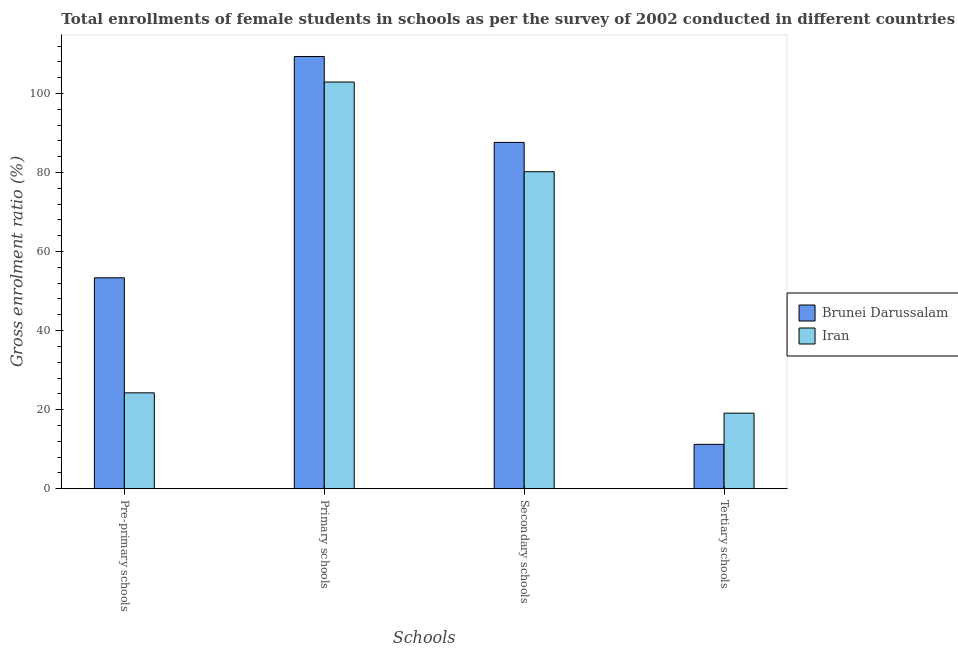How many different coloured bars are there?
Provide a short and direct response. 2. Are the number of bars per tick equal to the number of legend labels?
Make the answer very short. Yes. Are the number of bars on each tick of the X-axis equal?
Offer a terse response. Yes. How many bars are there on the 3rd tick from the left?
Your answer should be very brief. 2. How many bars are there on the 2nd tick from the right?
Your answer should be very brief. 2. What is the label of the 2nd group of bars from the left?
Give a very brief answer. Primary schools. What is the gross enrolment ratio(female) in secondary schools in Iran?
Offer a terse response. 80.21. Across all countries, what is the maximum gross enrolment ratio(female) in pre-primary schools?
Ensure brevity in your answer.  53.37. Across all countries, what is the minimum gross enrolment ratio(female) in tertiary schools?
Offer a terse response. 11.21. In which country was the gross enrolment ratio(female) in primary schools maximum?
Keep it short and to the point. Brunei Darussalam. In which country was the gross enrolment ratio(female) in secondary schools minimum?
Make the answer very short. Iran. What is the total gross enrolment ratio(female) in secondary schools in the graph?
Provide a short and direct response. 167.84. What is the difference between the gross enrolment ratio(female) in secondary schools in Brunei Darussalam and that in Iran?
Give a very brief answer. 7.42. What is the difference between the gross enrolment ratio(female) in pre-primary schools in Iran and the gross enrolment ratio(female) in tertiary schools in Brunei Darussalam?
Ensure brevity in your answer.  13.04. What is the average gross enrolment ratio(female) in pre-primary schools per country?
Offer a terse response. 38.81. What is the difference between the gross enrolment ratio(female) in pre-primary schools and gross enrolment ratio(female) in secondary schools in Brunei Darussalam?
Offer a very short reply. -34.26. In how many countries, is the gross enrolment ratio(female) in primary schools greater than 76 %?
Make the answer very short. 2. What is the ratio of the gross enrolment ratio(female) in pre-primary schools in Brunei Darussalam to that in Iran?
Give a very brief answer. 2.2. Is the difference between the gross enrolment ratio(female) in pre-primary schools in Brunei Darussalam and Iran greater than the difference between the gross enrolment ratio(female) in primary schools in Brunei Darussalam and Iran?
Keep it short and to the point. Yes. What is the difference between the highest and the second highest gross enrolment ratio(female) in tertiary schools?
Keep it short and to the point. 7.9. What is the difference between the highest and the lowest gross enrolment ratio(female) in primary schools?
Provide a succinct answer. 6.47. What does the 2nd bar from the left in Secondary schools represents?
Keep it short and to the point. Iran. What does the 2nd bar from the right in Pre-primary schools represents?
Provide a short and direct response. Brunei Darussalam. Is it the case that in every country, the sum of the gross enrolment ratio(female) in pre-primary schools and gross enrolment ratio(female) in primary schools is greater than the gross enrolment ratio(female) in secondary schools?
Your answer should be very brief. Yes. How many bars are there?
Ensure brevity in your answer.  8. Are all the bars in the graph horizontal?
Provide a succinct answer. No. How many countries are there in the graph?
Ensure brevity in your answer.  2. Are the values on the major ticks of Y-axis written in scientific E-notation?
Your answer should be compact. No. Does the graph contain grids?
Offer a terse response. No. How many legend labels are there?
Give a very brief answer. 2. How are the legend labels stacked?
Keep it short and to the point. Vertical. What is the title of the graph?
Your answer should be very brief. Total enrollments of female students in schools as per the survey of 2002 conducted in different countries. What is the label or title of the X-axis?
Provide a succinct answer. Schools. What is the Gross enrolment ratio (%) of Brunei Darussalam in Pre-primary schools?
Make the answer very short. 53.37. What is the Gross enrolment ratio (%) of Iran in Pre-primary schools?
Provide a succinct answer. 24.25. What is the Gross enrolment ratio (%) of Brunei Darussalam in Primary schools?
Provide a succinct answer. 109.37. What is the Gross enrolment ratio (%) in Iran in Primary schools?
Provide a short and direct response. 102.9. What is the Gross enrolment ratio (%) in Brunei Darussalam in Secondary schools?
Your answer should be compact. 87.63. What is the Gross enrolment ratio (%) in Iran in Secondary schools?
Your answer should be compact. 80.21. What is the Gross enrolment ratio (%) in Brunei Darussalam in Tertiary schools?
Ensure brevity in your answer.  11.21. What is the Gross enrolment ratio (%) of Iran in Tertiary schools?
Your answer should be very brief. 19.11. Across all Schools, what is the maximum Gross enrolment ratio (%) of Brunei Darussalam?
Give a very brief answer. 109.37. Across all Schools, what is the maximum Gross enrolment ratio (%) in Iran?
Keep it short and to the point. 102.9. Across all Schools, what is the minimum Gross enrolment ratio (%) of Brunei Darussalam?
Your answer should be very brief. 11.21. Across all Schools, what is the minimum Gross enrolment ratio (%) of Iran?
Your answer should be compact. 19.11. What is the total Gross enrolment ratio (%) in Brunei Darussalam in the graph?
Make the answer very short. 261.58. What is the total Gross enrolment ratio (%) in Iran in the graph?
Keep it short and to the point. 226.47. What is the difference between the Gross enrolment ratio (%) of Brunei Darussalam in Pre-primary schools and that in Primary schools?
Provide a short and direct response. -56. What is the difference between the Gross enrolment ratio (%) of Iran in Pre-primary schools and that in Primary schools?
Your answer should be compact. -78.65. What is the difference between the Gross enrolment ratio (%) of Brunei Darussalam in Pre-primary schools and that in Secondary schools?
Provide a short and direct response. -34.26. What is the difference between the Gross enrolment ratio (%) of Iran in Pre-primary schools and that in Secondary schools?
Ensure brevity in your answer.  -55.96. What is the difference between the Gross enrolment ratio (%) in Brunei Darussalam in Pre-primary schools and that in Tertiary schools?
Give a very brief answer. 42.16. What is the difference between the Gross enrolment ratio (%) of Iran in Pre-primary schools and that in Tertiary schools?
Provide a succinct answer. 5.14. What is the difference between the Gross enrolment ratio (%) of Brunei Darussalam in Primary schools and that in Secondary schools?
Your answer should be compact. 21.74. What is the difference between the Gross enrolment ratio (%) of Iran in Primary schools and that in Secondary schools?
Give a very brief answer. 22.69. What is the difference between the Gross enrolment ratio (%) of Brunei Darussalam in Primary schools and that in Tertiary schools?
Give a very brief answer. 98.16. What is the difference between the Gross enrolment ratio (%) in Iran in Primary schools and that in Tertiary schools?
Ensure brevity in your answer.  83.79. What is the difference between the Gross enrolment ratio (%) of Brunei Darussalam in Secondary schools and that in Tertiary schools?
Your answer should be very brief. 76.42. What is the difference between the Gross enrolment ratio (%) of Iran in Secondary schools and that in Tertiary schools?
Keep it short and to the point. 61.1. What is the difference between the Gross enrolment ratio (%) in Brunei Darussalam in Pre-primary schools and the Gross enrolment ratio (%) in Iran in Primary schools?
Your answer should be very brief. -49.53. What is the difference between the Gross enrolment ratio (%) in Brunei Darussalam in Pre-primary schools and the Gross enrolment ratio (%) in Iran in Secondary schools?
Keep it short and to the point. -26.84. What is the difference between the Gross enrolment ratio (%) in Brunei Darussalam in Pre-primary schools and the Gross enrolment ratio (%) in Iran in Tertiary schools?
Give a very brief answer. 34.26. What is the difference between the Gross enrolment ratio (%) in Brunei Darussalam in Primary schools and the Gross enrolment ratio (%) in Iran in Secondary schools?
Ensure brevity in your answer.  29.16. What is the difference between the Gross enrolment ratio (%) in Brunei Darussalam in Primary schools and the Gross enrolment ratio (%) in Iran in Tertiary schools?
Your answer should be very brief. 90.26. What is the difference between the Gross enrolment ratio (%) of Brunei Darussalam in Secondary schools and the Gross enrolment ratio (%) of Iran in Tertiary schools?
Your answer should be very brief. 68.52. What is the average Gross enrolment ratio (%) in Brunei Darussalam per Schools?
Provide a succinct answer. 65.4. What is the average Gross enrolment ratio (%) in Iran per Schools?
Ensure brevity in your answer.  56.62. What is the difference between the Gross enrolment ratio (%) in Brunei Darussalam and Gross enrolment ratio (%) in Iran in Pre-primary schools?
Ensure brevity in your answer.  29.12. What is the difference between the Gross enrolment ratio (%) of Brunei Darussalam and Gross enrolment ratio (%) of Iran in Primary schools?
Provide a short and direct response. 6.47. What is the difference between the Gross enrolment ratio (%) in Brunei Darussalam and Gross enrolment ratio (%) in Iran in Secondary schools?
Offer a very short reply. 7.42. What is the difference between the Gross enrolment ratio (%) of Brunei Darussalam and Gross enrolment ratio (%) of Iran in Tertiary schools?
Ensure brevity in your answer.  -7.9. What is the ratio of the Gross enrolment ratio (%) of Brunei Darussalam in Pre-primary schools to that in Primary schools?
Offer a very short reply. 0.49. What is the ratio of the Gross enrolment ratio (%) in Iran in Pre-primary schools to that in Primary schools?
Keep it short and to the point. 0.24. What is the ratio of the Gross enrolment ratio (%) of Brunei Darussalam in Pre-primary schools to that in Secondary schools?
Provide a succinct answer. 0.61. What is the ratio of the Gross enrolment ratio (%) in Iran in Pre-primary schools to that in Secondary schools?
Offer a terse response. 0.3. What is the ratio of the Gross enrolment ratio (%) of Brunei Darussalam in Pre-primary schools to that in Tertiary schools?
Your answer should be very brief. 4.76. What is the ratio of the Gross enrolment ratio (%) in Iran in Pre-primary schools to that in Tertiary schools?
Ensure brevity in your answer.  1.27. What is the ratio of the Gross enrolment ratio (%) in Brunei Darussalam in Primary schools to that in Secondary schools?
Your answer should be compact. 1.25. What is the ratio of the Gross enrolment ratio (%) in Iran in Primary schools to that in Secondary schools?
Keep it short and to the point. 1.28. What is the ratio of the Gross enrolment ratio (%) of Brunei Darussalam in Primary schools to that in Tertiary schools?
Provide a succinct answer. 9.75. What is the ratio of the Gross enrolment ratio (%) of Iran in Primary schools to that in Tertiary schools?
Provide a succinct answer. 5.39. What is the ratio of the Gross enrolment ratio (%) in Brunei Darussalam in Secondary schools to that in Tertiary schools?
Offer a terse response. 7.81. What is the ratio of the Gross enrolment ratio (%) in Iran in Secondary schools to that in Tertiary schools?
Offer a terse response. 4.2. What is the difference between the highest and the second highest Gross enrolment ratio (%) of Brunei Darussalam?
Offer a very short reply. 21.74. What is the difference between the highest and the second highest Gross enrolment ratio (%) of Iran?
Provide a succinct answer. 22.69. What is the difference between the highest and the lowest Gross enrolment ratio (%) in Brunei Darussalam?
Give a very brief answer. 98.16. What is the difference between the highest and the lowest Gross enrolment ratio (%) in Iran?
Offer a very short reply. 83.79. 